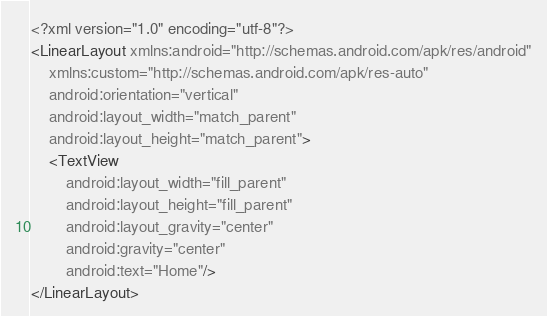Convert code to text. <code><loc_0><loc_0><loc_500><loc_500><_XML_><?xml version="1.0" encoding="utf-8"?>
<LinearLayout xmlns:android="http://schemas.android.com/apk/res/android"
    xmlns:custom="http://schemas.android.com/apk/res-auto"
    android:orientation="vertical"
    android:layout_width="match_parent"
    android:layout_height="match_parent">
    <TextView
        android:layout_width="fill_parent"
        android:layout_height="fill_parent"
        android:layout_gravity="center"
        android:gravity="center"
        android:text="Home"/>
</LinearLayout></code> 